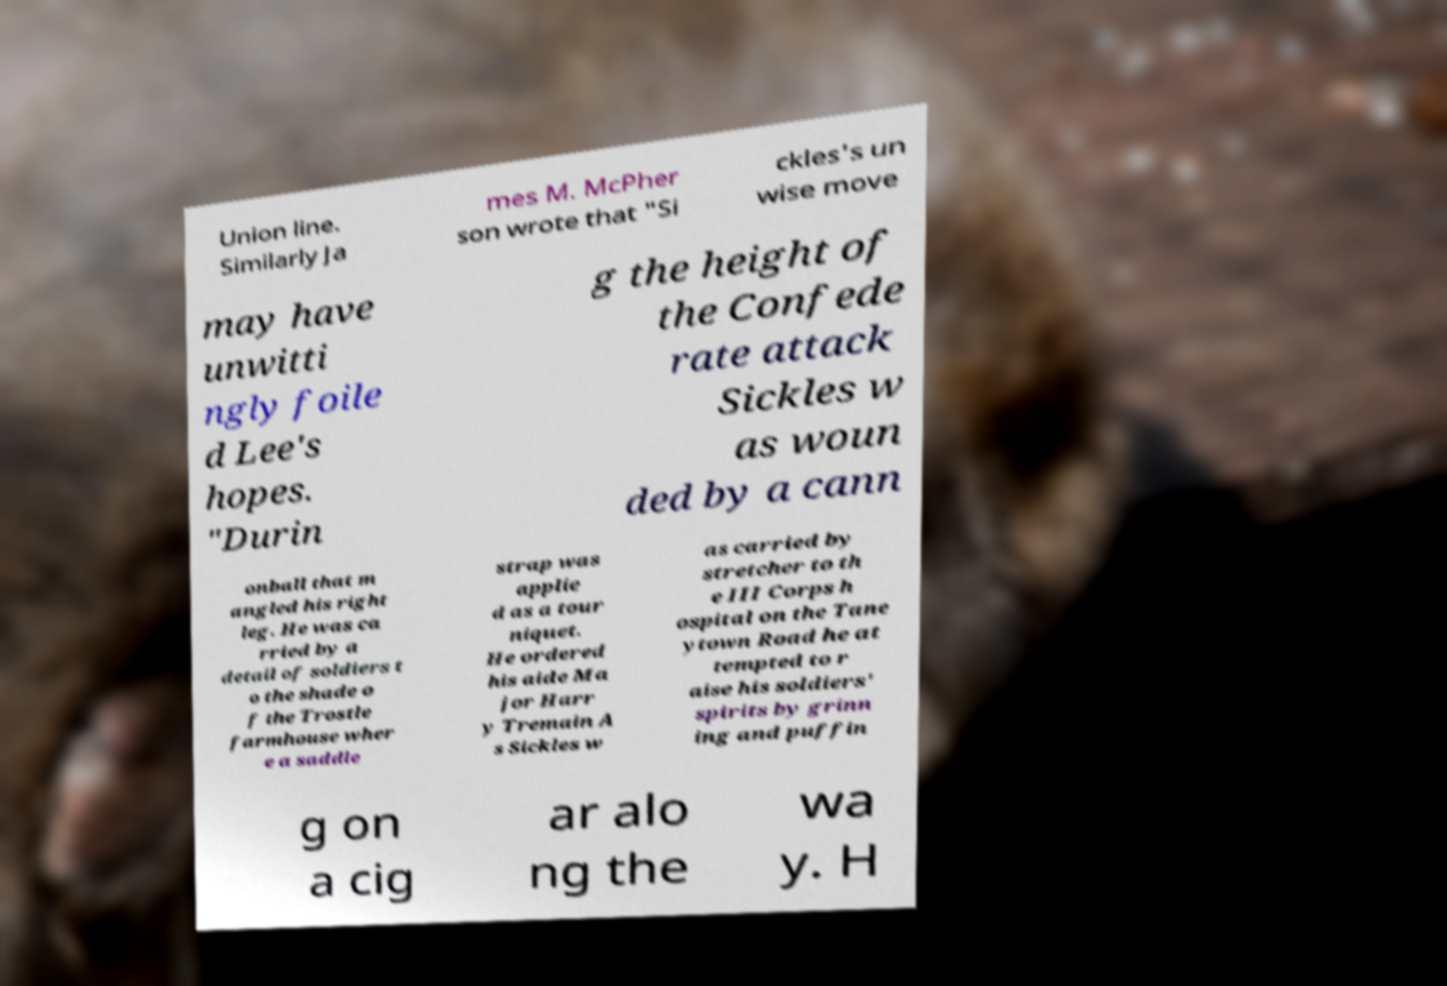Please read and relay the text visible in this image. What does it say? Union line. Similarly Ja mes M. McPher son wrote that "Si ckles's un wise move may have unwitti ngly foile d Lee's hopes. "Durin g the height of the Confede rate attack Sickles w as woun ded by a cann onball that m angled his right leg. He was ca rried by a detail of soldiers t o the shade o f the Trostle farmhouse wher e a saddle strap was applie d as a tour niquet. He ordered his aide Ma jor Harr y Tremain A s Sickles w as carried by stretcher to th e III Corps h ospital on the Tane ytown Road he at tempted to r aise his soldiers' spirits by grinn ing and puffin g on a cig ar alo ng the wa y. H 